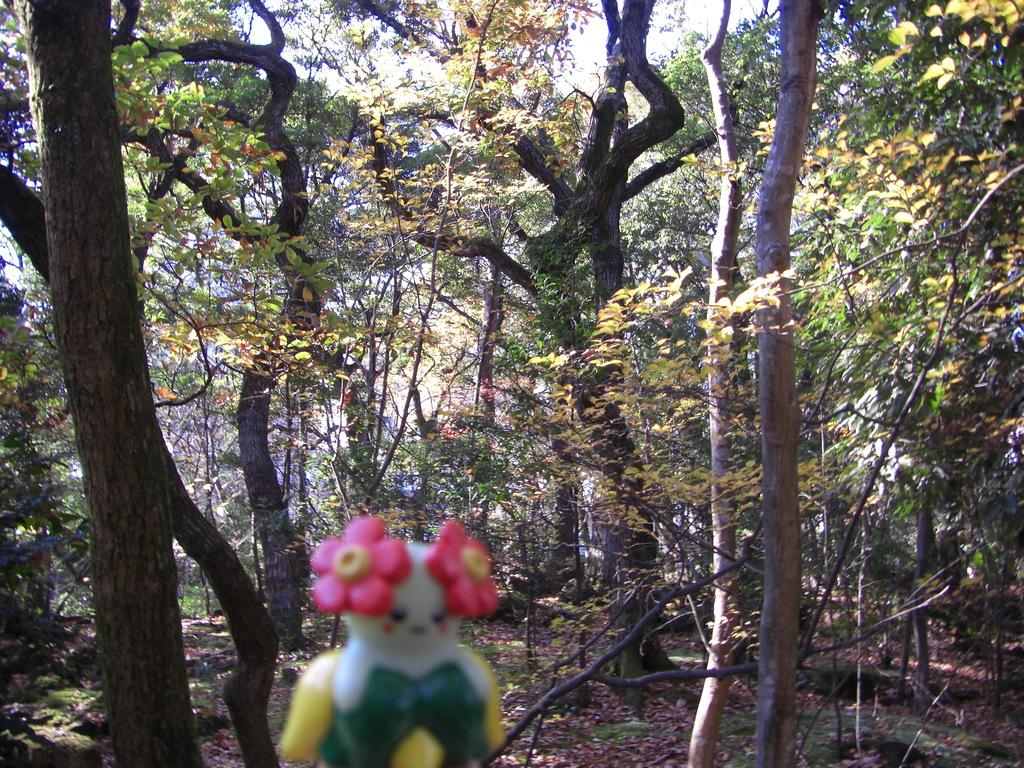What is the main object in the foreground of the image? There is a toy in the foreground of the image. How is the toy depicted in the image? The toy is blurred. What can be seen in the background of the image? There are trees and dry leaves on the grass in the background. What is visible in the sky in the background of the image? The sky is visible in the background of the image. What type of office furniture can be seen in the image? There is no office furniture present in the image; it features a blurred toy in the foreground and trees, dry leaves, and the sky in the background. 